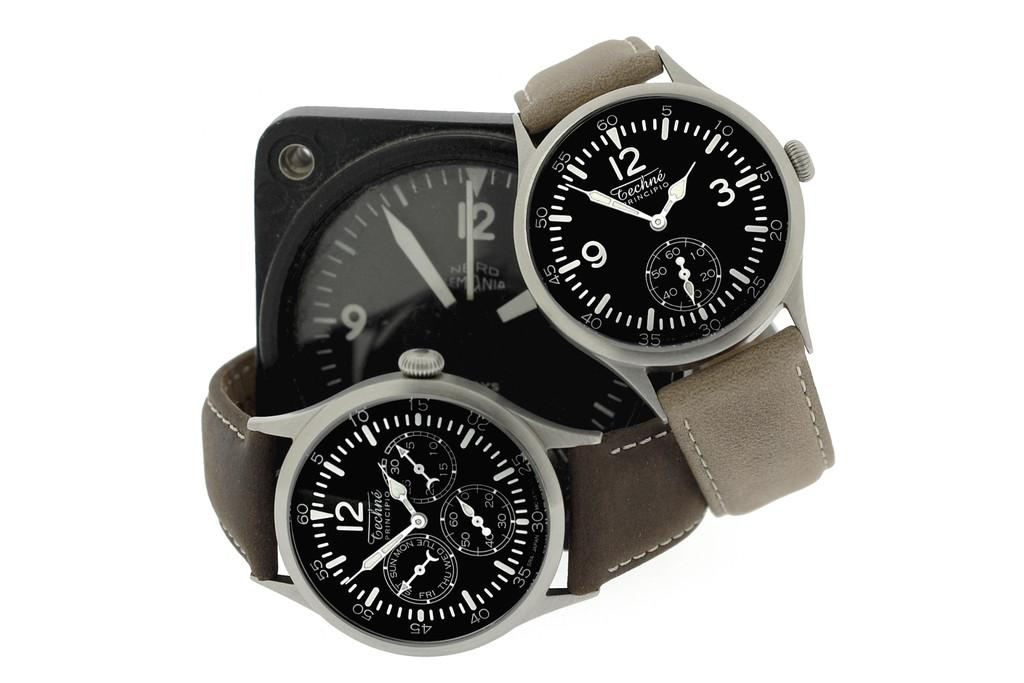<image>
Render a clear and concise summary of the photo. Two Techne brand watches sit on a white surface. 